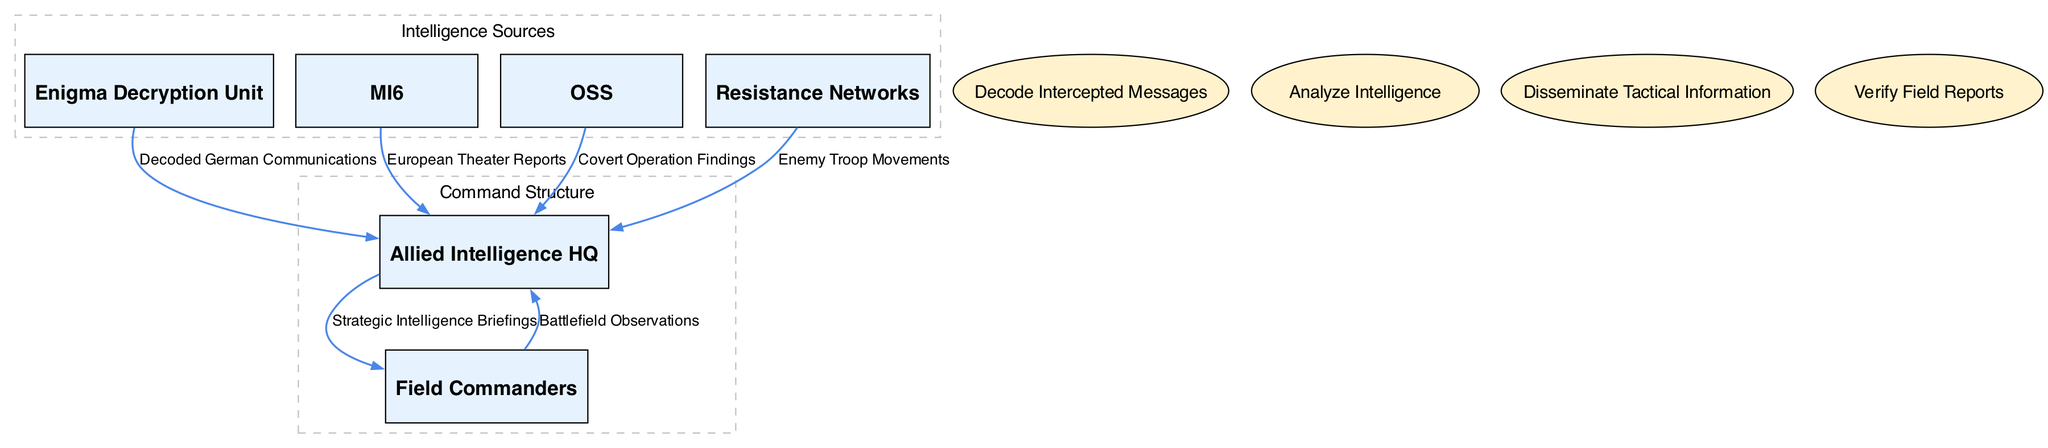What is the total number of entities in the diagram? The diagram lists six entities: Allied Intelligence HQ, Field Commanders, Enigma Decryption Unit, MI6, OSS, and Resistance Networks. Counting these gives us a total of six entities.
Answer: 6 Which entity is receiving "Decoded German Communications"? According to the data flow in the diagram, the "Decoded German Communications" flow is directed from the Enigma Decryption Unit to the Allied Intelligence HQ, indicating that the Allied Intelligence HQ is the recipient.
Answer: Allied Intelligence HQ How many processes are depicted in the diagram? The diagram includes four processes: Decode Intercepted Messages, Analyze Intelligence, Disseminate Tactical Information, and Verify Field Reports. Summing these processes gives a total of four.
Answer: 4 What type of reports does MI6 send to Allied Intelligence HQ? The diagram specifies that MI6 sends "European Theater Reports" to the Allied Intelligence HQ, providing insight into the intelligence shared between these entities.
Answer: European Theater Reports From which source do Field Commanders send their observations? Field Commanders send their "Battlefield Observations" back to the Allied Intelligence HQ. The label in the data flow directly indicates the source of these observations.
Answer: Allied Intelligence HQ Which entity is responsible for disseminating "Strategic Intelligence Briefings"? The data flow indicates that "Strategic Intelligence Briefings" are sent from the Allied Intelligence HQ to the Field Commanders, making Allied Intelligence HQ the responsible party for this dissemination.
Answer: Allied Intelligence HQ What is the role of the Enigma Decryption Unit in the intelligence flow? The Enigma Decryption Unit's role is to decode intercepted German communications, which are then sent to the Allied Intelligence HQ for further processing and analysis.
Answer: Decode Intercepted Messages Which flows involve Resistance Networks? The diagram shows that Resistance Networks contribute "Enemy Troop Movements" to the Allied Intelligence HQ. This indicates their role in supplying critical ground-level intelligence.
Answer: Enemy Troop Movements How do the processes relate to the overall flow of information? The processes are centered around the analysis and dissemination of intelligence. They connect the incoming data from sources to the eventual communication with field commanders, illustrating the systematic flow of military intelligence.
Answer: Analyze Intelligence 